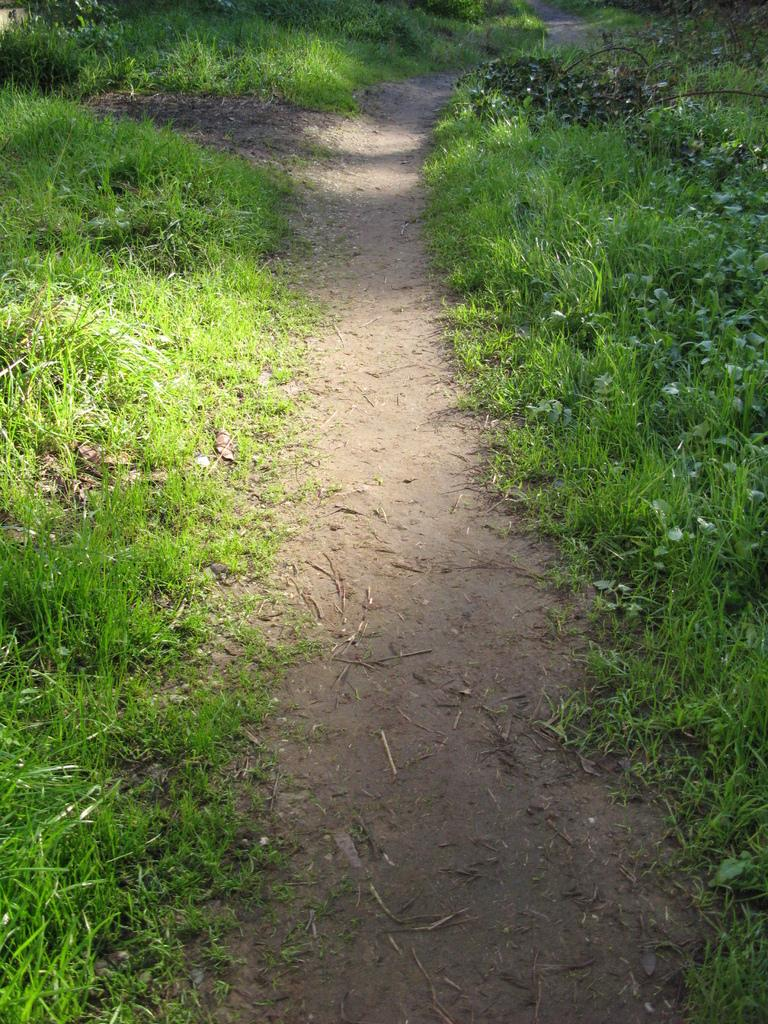What type of vegetation is present in the image? There is grass in the image. Where are the plants located in the image? The plants are on the right side of the image. How many houses can be seen in the image? There are no houses present in the image; it only features grass and plants. What type of stove is visible in the image? There is no stove present in the image. 